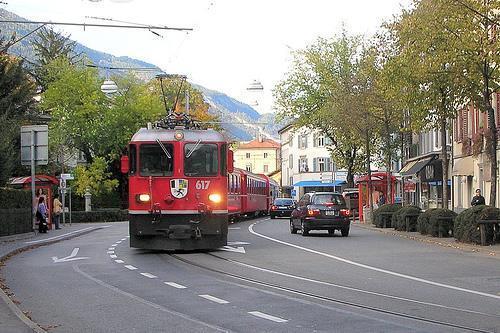How many cars are driving in the opposite direction of the street car?
Give a very brief answer. 2. 